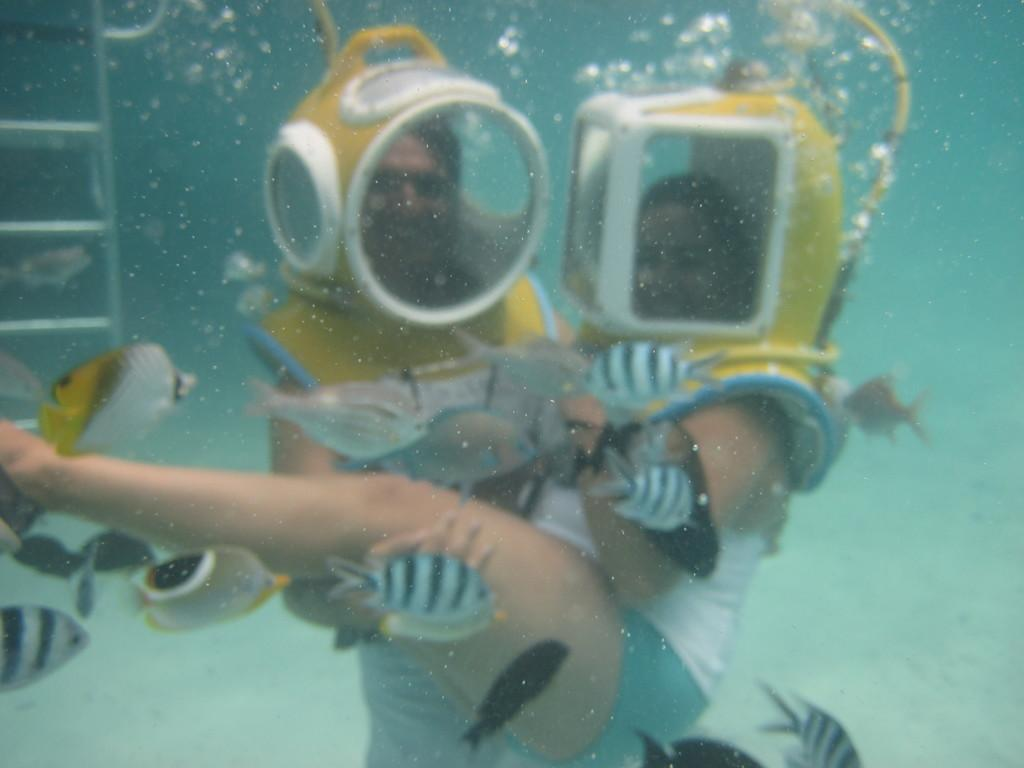What is the primary element in the image? There is water in the image. What can be found in the water? There are fishes in the water. What other object is present in the image? There is a ladder in the image. How many people are in the image? There are two people in the image. What type of bells can be heard ringing in the image? There are no bells present in the image, and therefore no sound can be heard. 